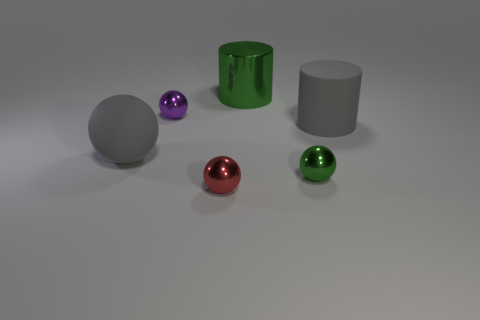Is the number of small red balls that are behind the large gray cylinder the same as the number of large yellow things?
Make the answer very short. Yes. What shape is the metallic thing that is the same size as the rubber cylinder?
Provide a succinct answer. Cylinder. What number of other things are the same shape as the red object?
Provide a short and direct response. 3. Is the size of the green metal sphere the same as the rubber object that is to the left of the green metal ball?
Give a very brief answer. No. What number of things are small objects that are on the left side of the green metal cylinder or tiny cyan rubber objects?
Your response must be concise. 2. There is a big green thing to the right of the gray sphere; what shape is it?
Your answer should be compact. Cylinder. Is the number of green shiny spheres that are in front of the big gray rubber sphere the same as the number of large gray matte balls that are to the right of the big green object?
Keep it short and to the point. No. There is a large thing that is to the left of the gray cylinder and on the right side of the purple shiny sphere; what is its color?
Keep it short and to the point. Green. What is the material of the green thing that is to the right of the metallic cylinder that is on the left side of the green metallic sphere?
Your answer should be compact. Metal. Is the size of the gray rubber ball the same as the red object?
Provide a succinct answer. No. 